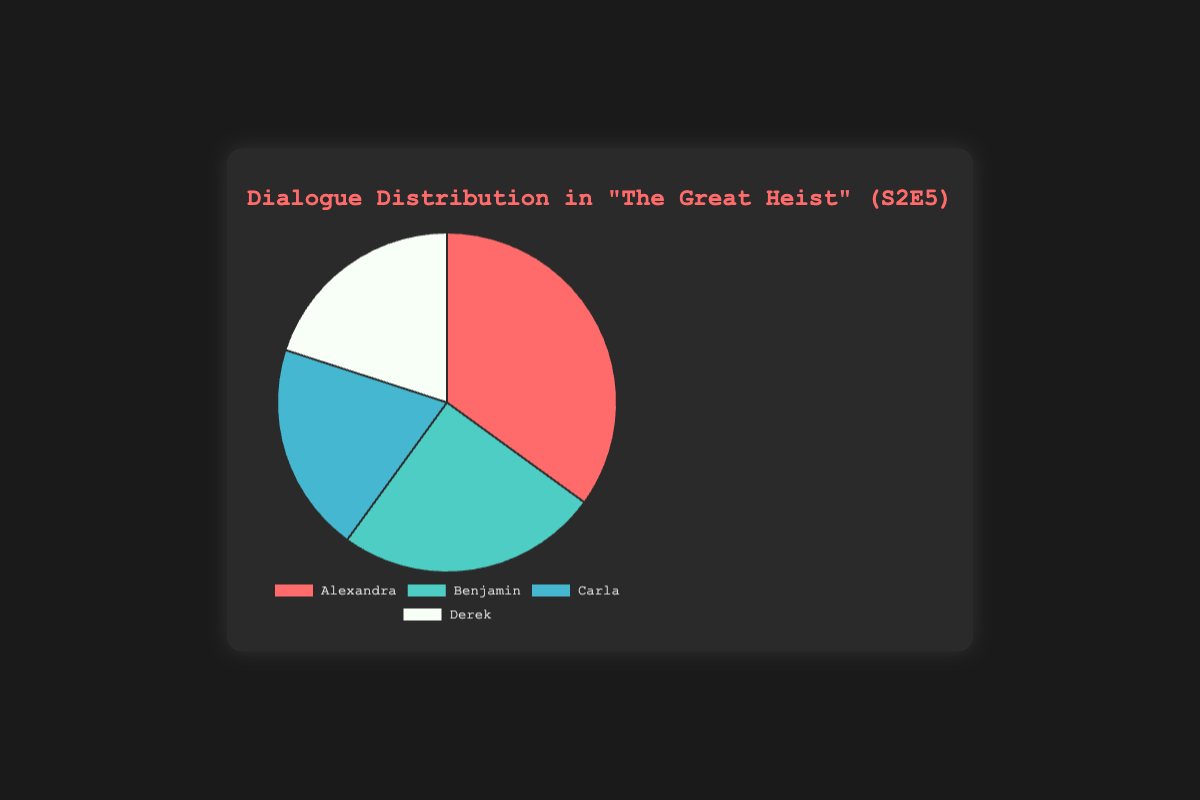Which character had the most dialogue in this episode? Alexandra had the highest percentage of dialogue, which is 35%.
Answer: Alexandra What is the combined dialogue percentage for Carla and Derek? Carla and Derek both have a dialogue percentage of 20%. Adding these together gives 20% + 20% = 40%.
Answer: 40% How much more dialogue does Alexandra have compared to Benjamin? Alexandra has 35% of the dialogue, while Benjamin has 25%. The difference is 35% - 25% = 10%.
Answer: 10% Which characters have equal dialogue percentages? Both Carla and Derek have the same dialogue percentage of 20%.
Answer: Carla and Derek Who has the second highest amount of dialogue? Benjamin has the second highest amount of dialogue at 25%, with Alexandra having the highest at 35%.
Answer: Benjamin If the episode's total dialogue was split evenly among the characters, what would be the difference between Alexandra's current percentage and this even split? There are four characters, so an even split would be 100% / 4 = 25%. The difference between Alexandra’s percentage (35%) and this even split (25%) is 35% - 25% = 10%.
Answer: 10% Which character has 15% less dialogue than Alexandra? Benjamin has 25% dialogue, which is 35% - 25% = 10% less than Alexandra's 35%. However, this percentage difference might be an error. Please check again as exact figures like these often don't match due to rounding issues.
Answer: Benjamin What is the average dialogue percentage among the main characters? The total percentage of dialogue is 35% + 25% + 20% + 20% = 100%. With four characters, the average percentage is 100% / 4 = 25%.
Answer: 25% What color is associated with Derek in the chart? According to the code, Derek's color in the pie chart is white, as the background color listed is a light color (#f7fff7).
Answer: White Calculate the percentage difference between the dialogues of Alexandra and Carla. Alexandra has 35% and Carla has 20%. The percentage difference is calculated as (35% - 20%) / 20% * 100% = 75%.
Answer: 75% 